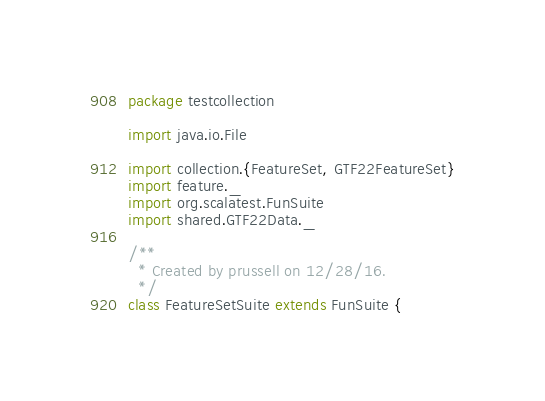<code> <loc_0><loc_0><loc_500><loc_500><_Scala_>package testcollection

import java.io.File

import collection.{FeatureSet, GTF22FeatureSet}
import feature._
import org.scalatest.FunSuite
import shared.GTF22Data._

/**
  * Created by prussell on 12/28/16.
  */
class FeatureSetSuite extends FunSuite {
</code> 